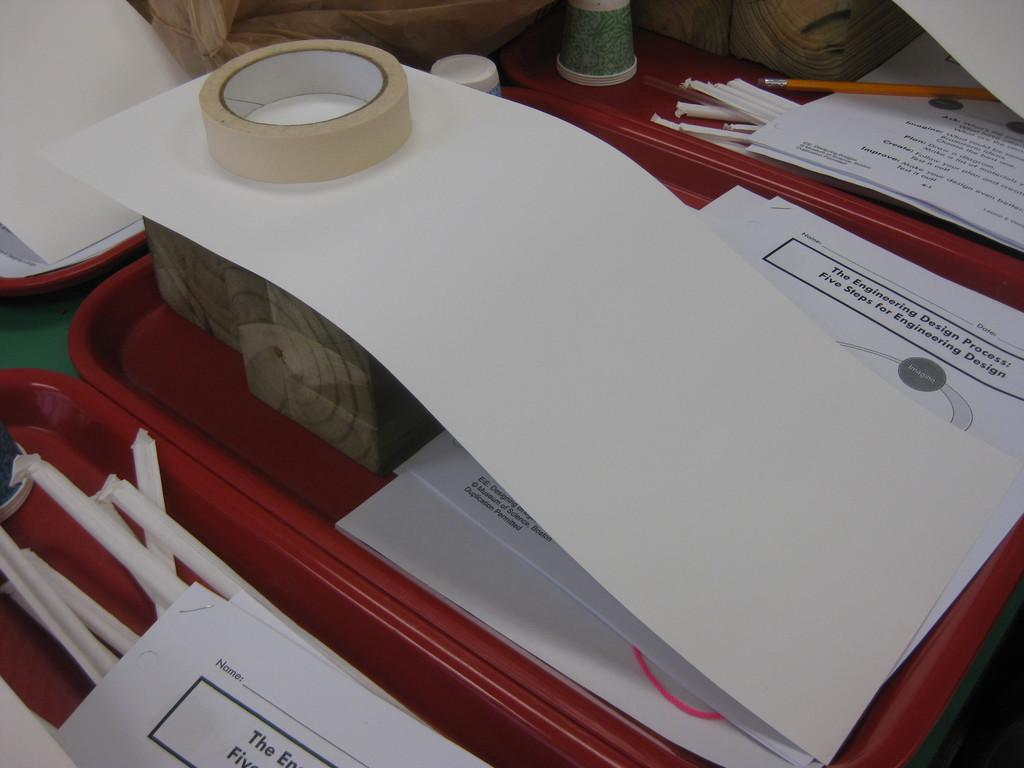What type of stationery items can be seen in the image? There are papers, pencils, and tape in the image. What type of containers are present in the image? There are cups and boxes in the image. How are the items organized in the image? The items are placed in several trays. What can be seen in the background of the image? There are wood blocks in the background of the image. Can you describe the snail crawling on the papers in the image? There is no snail present in the image; it only features papers, pencils, cups, boxes, tape, trays, and wood blocks. 